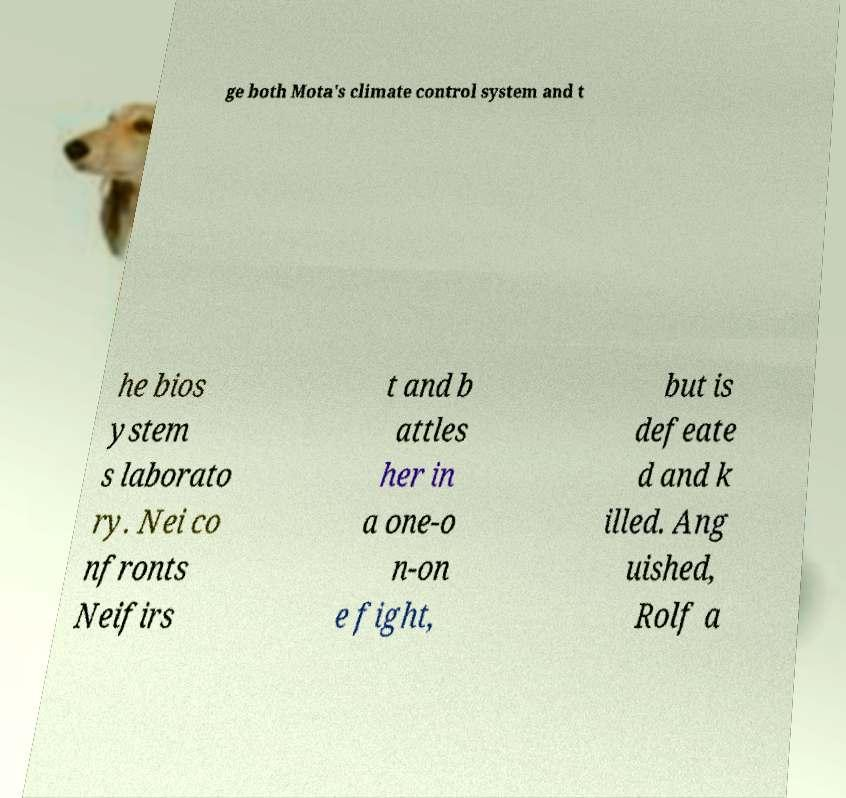Please identify and transcribe the text found in this image. ge both Mota's climate control system and t he bios ystem s laborato ry. Nei co nfronts Neifirs t and b attles her in a one-o n-on e fight, but is defeate d and k illed. Ang uished, Rolf a 